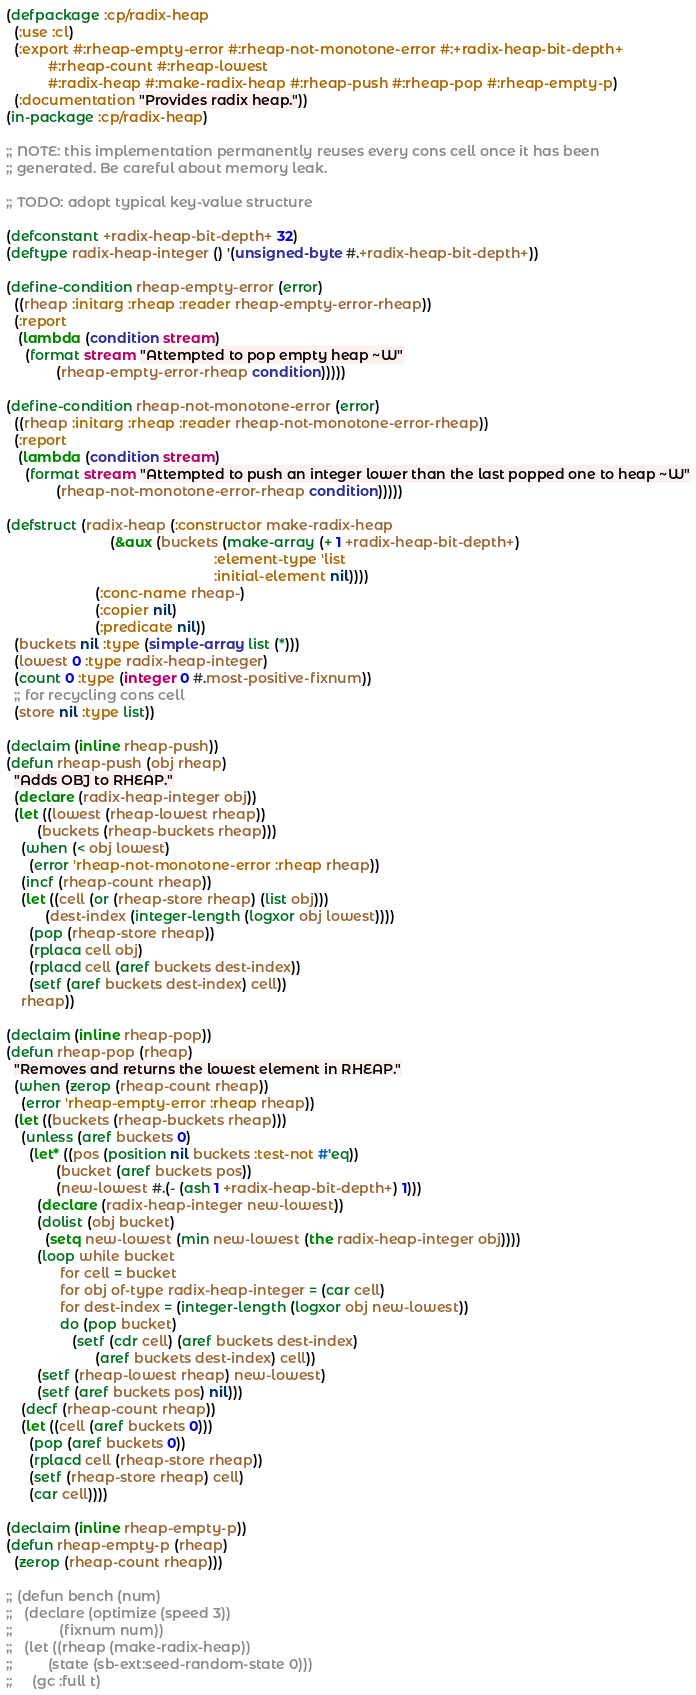<code> <loc_0><loc_0><loc_500><loc_500><_Lisp_>(defpackage :cp/radix-heap
  (:use :cl)
  (:export #:rheap-empty-error #:rheap-not-monotone-error #:+radix-heap-bit-depth+
           #:rheap-count #:rheap-lowest
           #:radix-heap #:make-radix-heap #:rheap-push #:rheap-pop #:rheap-empty-p)
  (:documentation "Provides radix heap."))
(in-package :cp/radix-heap)

;; NOTE: this implementation permanently reuses every cons cell once it has been
;; generated. Be careful about memory leak.

;; TODO: adopt typical key-value structure

(defconstant +radix-heap-bit-depth+ 32)
(deftype radix-heap-integer () '(unsigned-byte #.+radix-heap-bit-depth+))

(define-condition rheap-empty-error (error)
  ((rheap :initarg :rheap :reader rheap-empty-error-rheap))
  (:report
   (lambda (condition stream)
     (format stream "Attempted to pop empty heap ~W"
             (rheap-empty-error-rheap condition)))))

(define-condition rheap-not-monotone-error (error)
  ((rheap :initarg :rheap :reader rheap-not-monotone-error-rheap))
  (:report
   (lambda (condition stream)
     (format stream "Attempted to push an integer lower than the last popped one to heap ~W"
             (rheap-not-monotone-error-rheap condition)))))

(defstruct (radix-heap (:constructor make-radix-heap
                           (&aux (buckets (make-array (+ 1 +radix-heap-bit-depth+)
                                                      :element-type 'list
                                                      :initial-element nil))))
                       (:conc-name rheap-)
                       (:copier nil)
                       (:predicate nil))
  (buckets nil :type (simple-array list (*)))
  (lowest 0 :type radix-heap-integer)
  (count 0 :type (integer 0 #.most-positive-fixnum))
  ;; for recycling cons cell
  (store nil :type list))

(declaim (inline rheap-push))
(defun rheap-push (obj rheap)
  "Adds OBJ to RHEAP."
  (declare (radix-heap-integer obj))
  (let ((lowest (rheap-lowest rheap))
        (buckets (rheap-buckets rheap)))
    (when (< obj lowest)
      (error 'rheap-not-monotone-error :rheap rheap))
    (incf (rheap-count rheap))
    (let ((cell (or (rheap-store rheap) (list obj)))
          (dest-index (integer-length (logxor obj lowest))))
      (pop (rheap-store rheap))
      (rplaca cell obj)
      (rplacd cell (aref buckets dest-index))
      (setf (aref buckets dest-index) cell))
    rheap))

(declaim (inline rheap-pop))
(defun rheap-pop (rheap)
  "Removes and returns the lowest element in RHEAP."
  (when (zerop (rheap-count rheap))
    (error 'rheap-empty-error :rheap rheap))
  (let ((buckets (rheap-buckets rheap)))
    (unless (aref buckets 0)
      (let* ((pos (position nil buckets :test-not #'eq))
             (bucket (aref buckets pos))
             (new-lowest #.(- (ash 1 +radix-heap-bit-depth+) 1)))
        (declare (radix-heap-integer new-lowest))
        (dolist (obj bucket)
          (setq new-lowest (min new-lowest (the radix-heap-integer obj))))
        (loop while bucket
              for cell = bucket
              for obj of-type radix-heap-integer = (car cell)
              for dest-index = (integer-length (logxor obj new-lowest))
              do (pop bucket)
                 (setf (cdr cell) (aref buckets dest-index)
                       (aref buckets dest-index) cell))
        (setf (rheap-lowest rheap) new-lowest)
        (setf (aref buckets pos) nil)))
    (decf (rheap-count rheap))
    (let ((cell (aref buckets 0)))
      (pop (aref buckets 0))
      (rplacd cell (rheap-store rheap))
      (setf (rheap-store rheap) cell)
      (car cell))))

(declaim (inline rheap-empty-p))
(defun rheap-empty-p (rheap)
  (zerop (rheap-count rheap)))

;; (defun bench (num)
;;   (declare (optimize (speed 3))
;;            (fixnum num))
;;   (let ((rheap (make-radix-heap))
;;         (state (sb-ext:seed-random-state 0)))
;;     (gc :full t)</code> 